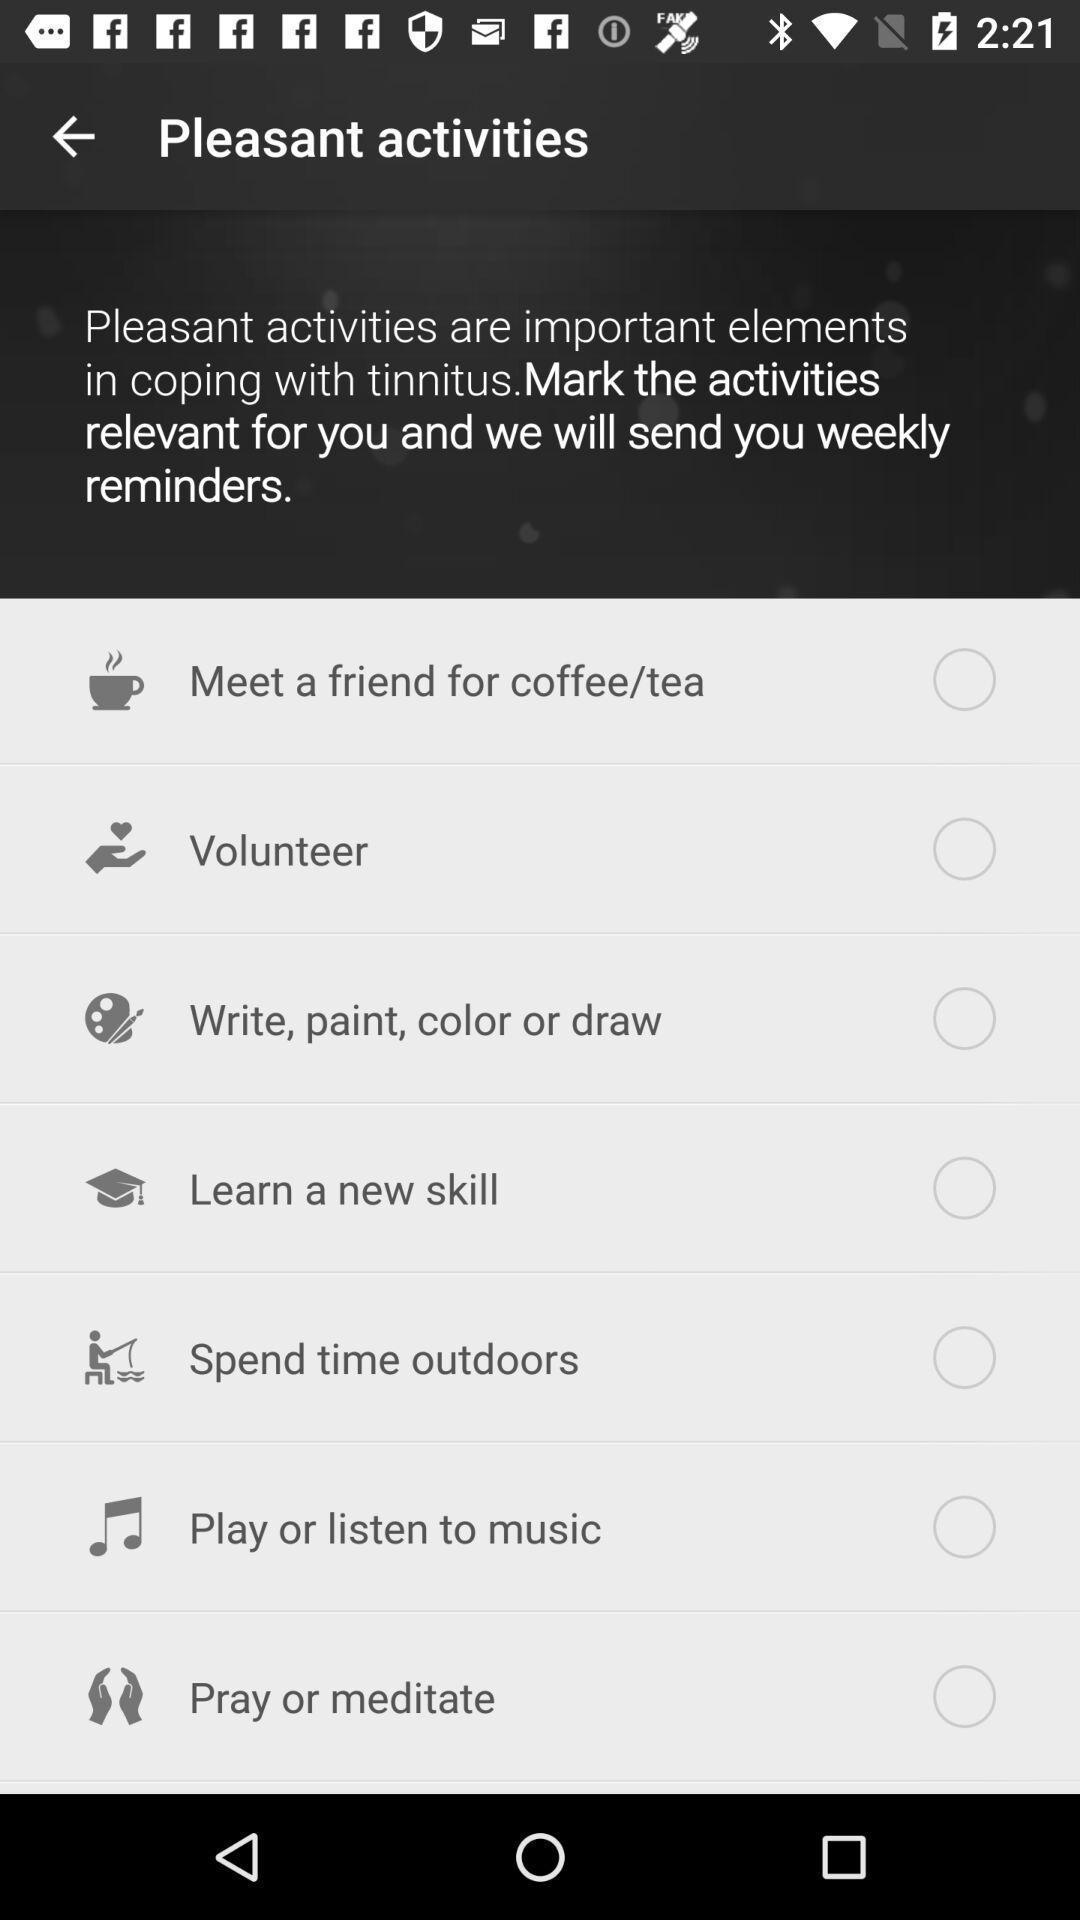Tell me about the visual elements in this screen capture. Page displays list of activities in app. 